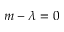Convert formula to latex. <formula><loc_0><loc_0><loc_500><loc_500>m - \lambda = 0</formula> 